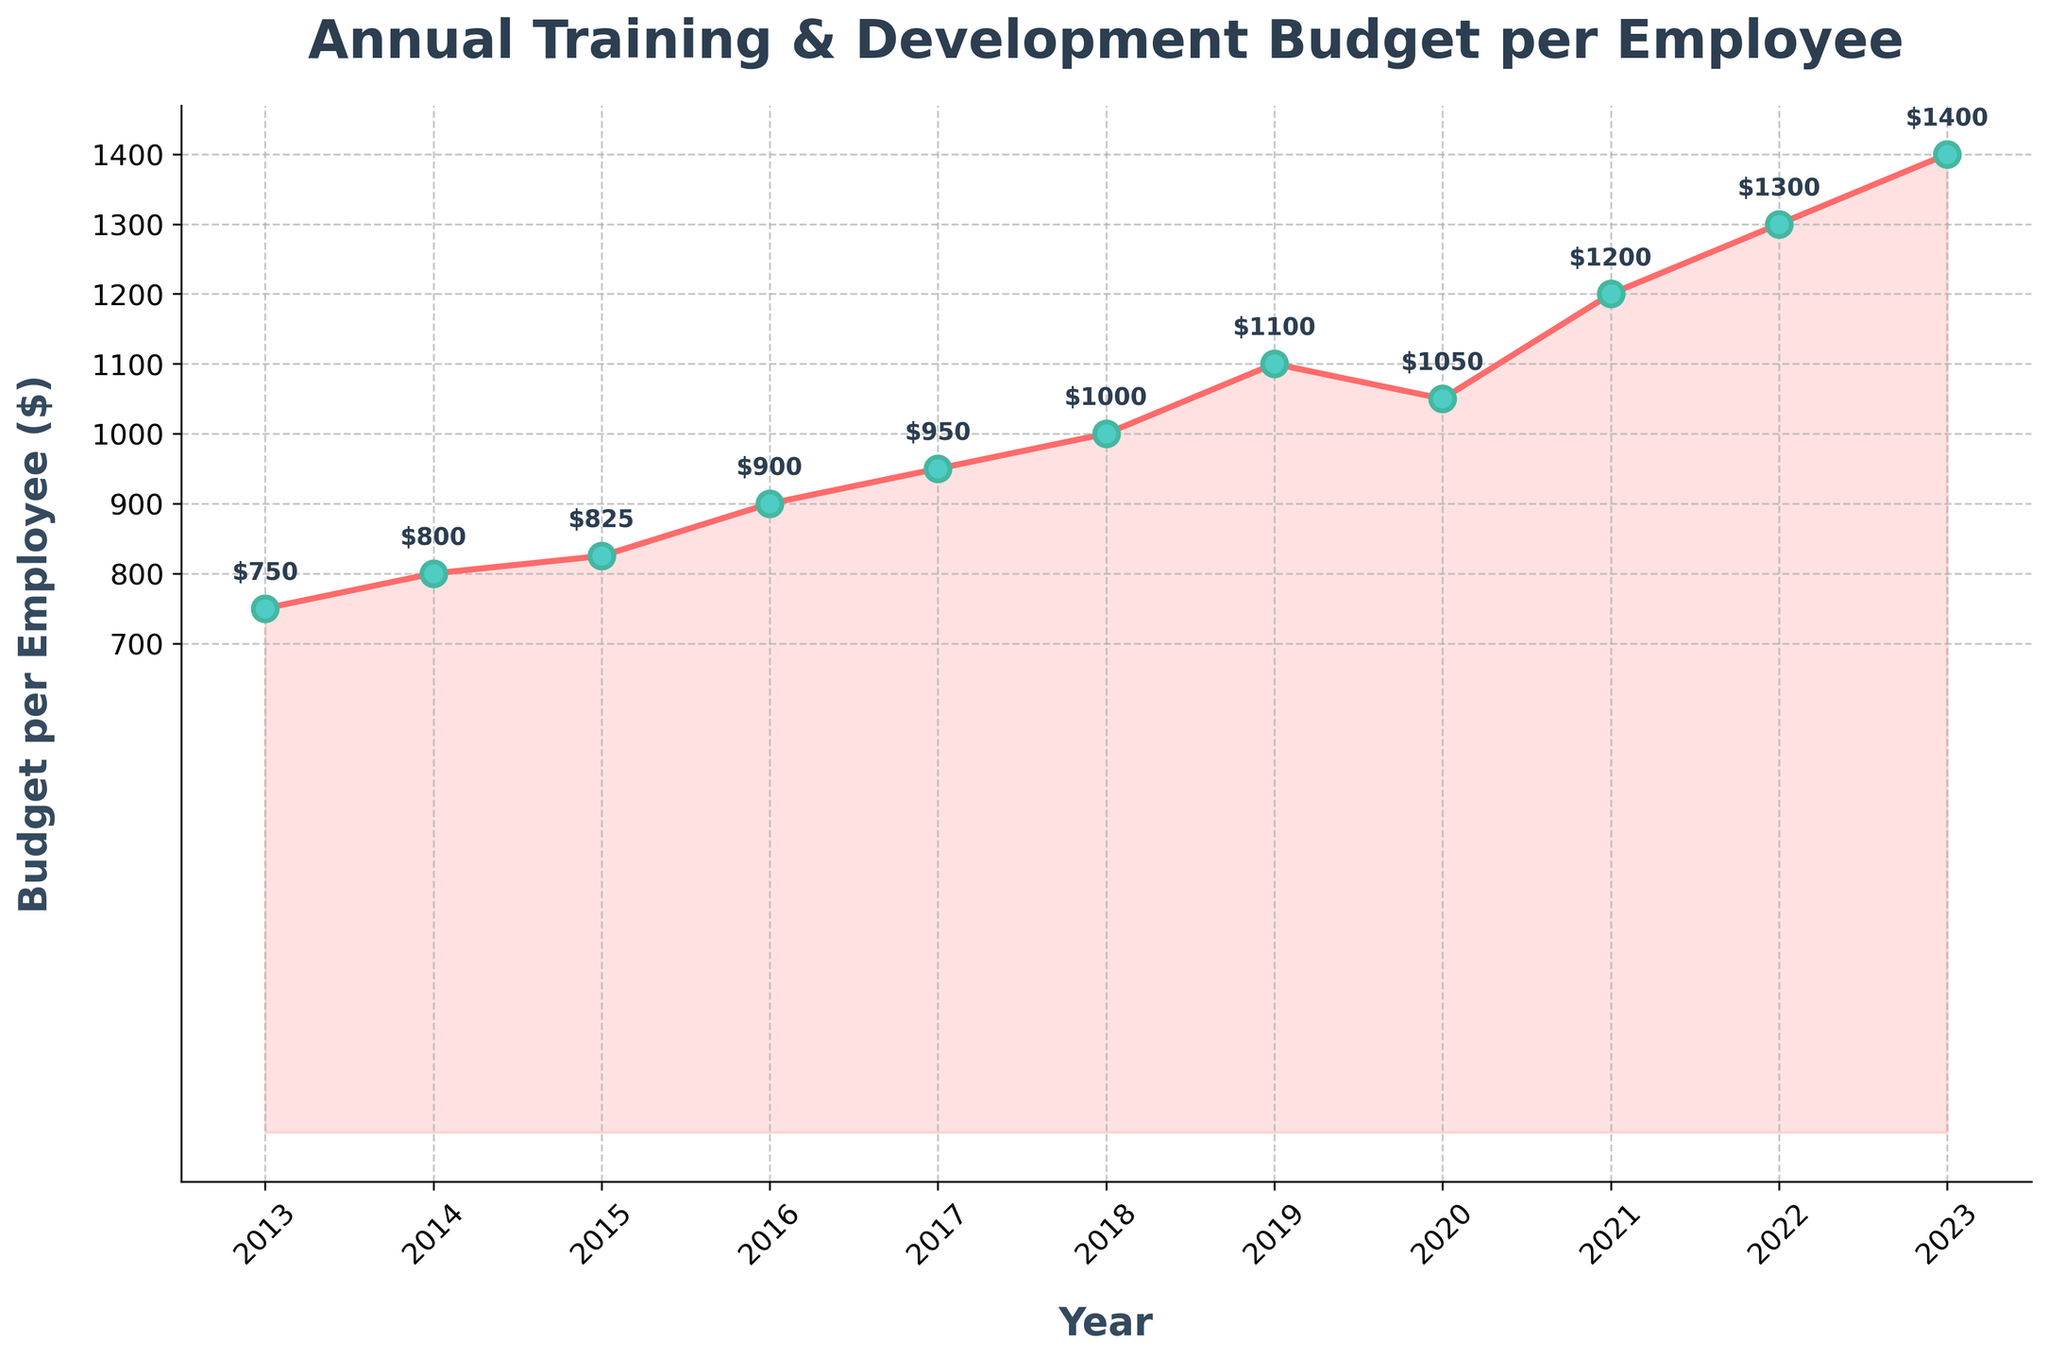What is the trend in the annual training and development budget per employee from 2013 to 2023? The line chart shows an upward trend in the annual training and development budget per employee from 2013 ($750) to 2023 ($1400), with minor fluctuations, such as a slight dip in 2020.
Answer: Upward trend Which year had the highest budget allocation per employee? From the chart, it is evident that 2023 had the highest budget allocation per employee at $1400.
Answer: 2023 Did the budget ever decrease from one year to the next? If so, when? Yes, the budget decreased from 2019 ($1100) to 2020 ($1050). This is observable from the line dipping slightly between these two years.
Answer: 2019 to 2020 What is the total budget allocation per employee over the decade? To find the total, sum the budgets from each year: 750 + 800 + 825 + 900 + 950 + 1000 + 1100 + 1050 + 1200 + 1300 + 1400 = 12275.
Answer: 12275 Which year had the smallest increase in the budget compared to the previous year? The smallest increase occurred between 2014 ($800) and 2015 ($825), which is $25.
Answer: 2014 to 2015 On average, how much did the budget grow each year over this period? The average annual increase can be calculated by taking the overall increase ($1400 - $750 = $650) and dividing it by the number of years (10). So the average growth per year is $650/10 = $65.
Answer: $65 How does the budget in 2020 compare to 2021? The budget in 2020 was $1050, while in 2021 it was $1200. This indicates that the budget increased by $150 from 2020 to 2021.
Answer: Increased by $150 By how much did the budget increase from 2018 to 2023? The budget in 2018 was $1000 and in 2023 it was $1400. The increase is $1400 - $1000 = $400.
Answer: $400 What is the average budget allocation per employee over these years? To find the average budget per year, sum the budgets from each year (12275) and divide it by the number of years (11): 12275 / 11 ≈ $1115.
Answer: $1115 Is the budget in 2022 more than the sum of the budgets from 2013 and 2014? The budget in 2022 was $1300. The sum of the budgets from 2013 ($750) and 2014 ($800) is $1550, which is more than the 2022 budget.
Answer: No 